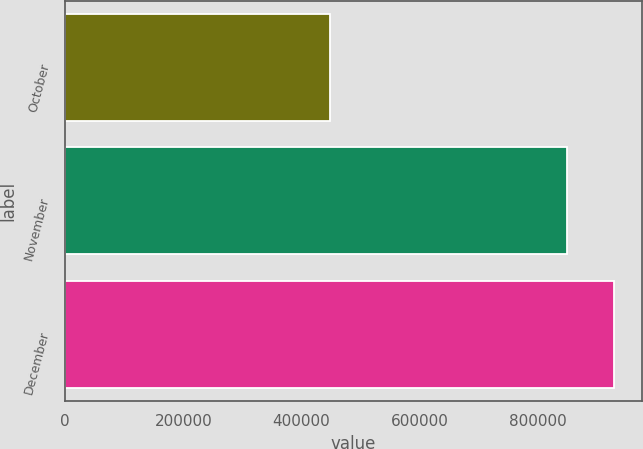<chart> <loc_0><loc_0><loc_500><loc_500><bar_chart><fcel>October<fcel>November<fcel>December<nl><fcel>447700<fcel>849200<fcel>929400<nl></chart> 